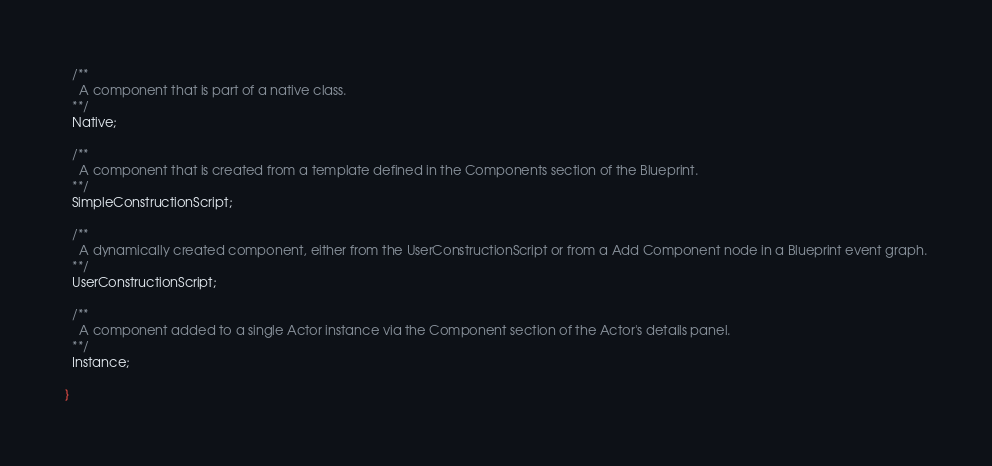Convert code to text. <code><loc_0><loc_0><loc_500><loc_500><_Haxe_>  /**
    A component that is part of a native class.
  **/
  Native;
  
  /**
    A component that is created from a template defined in the Components section of the Blueprint.
  **/
  SimpleConstructionScript;
  
  /**
    A dynamically created component, either from the UserConstructionScript or from a Add Component node in a Blueprint event graph.
  **/
  UserConstructionScript;
  
  /**
    A component added to a single Actor instance via the Component section of the Actor's details panel.
  **/
  Instance;
  
}
</code> 